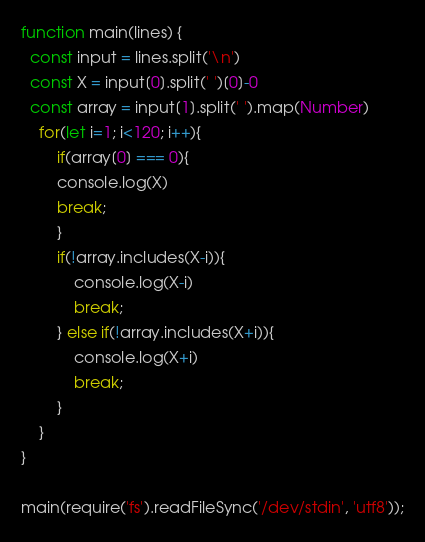Convert code to text. <code><loc_0><loc_0><loc_500><loc_500><_JavaScript_>function main(lines) {
  const input = lines.split('\n')
  const X = input[0].split(' ')[0]-0
  const array = input[1].split(' ').map(Number)
    for(let i=1; i<120; i++){
        if(array[0] === 0){
        console.log(X)
        break;
        }
        if(!array.includes(X-i)){
            console.log(X-i)
            break;
        } else if(!array.includes(X+i)){
            console.log(X+i)
            break;
        }
    }
}

main(require('fs').readFileSync('/dev/stdin', 'utf8'));

</code> 